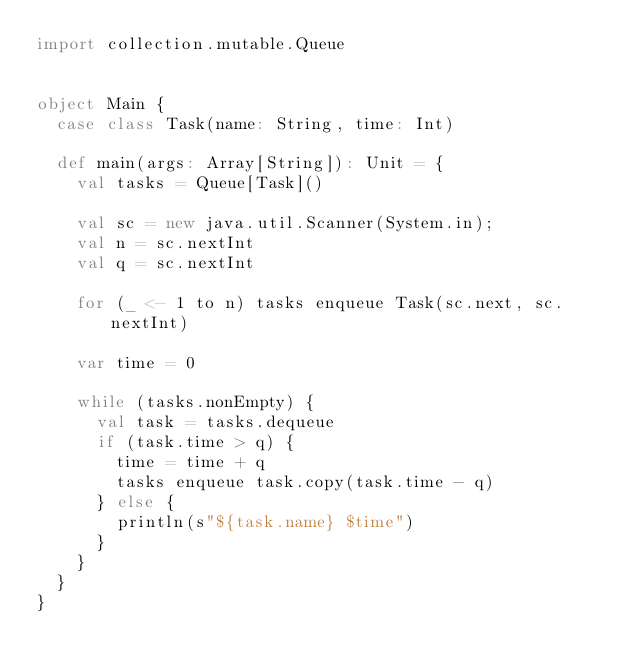Convert code to text. <code><loc_0><loc_0><loc_500><loc_500><_Scala_>import collection.mutable.Queue


object Main {
  case class Task(name: String, time: Int)

  def main(args: Array[String]): Unit = {
    val tasks = Queue[Task]()

    val sc = new java.util.Scanner(System.in);
    val n = sc.nextInt
    val q = sc.nextInt

    for (_ <- 1 to n) tasks enqueue Task(sc.next, sc.nextInt)

    var time = 0

    while (tasks.nonEmpty) {
      val task = tasks.dequeue
      if (task.time > q) {
        time = time + q
        tasks enqueue task.copy(task.time - q)
      } else {
        println(s"${task.name} $time")
      }
    }
  }
}</code> 